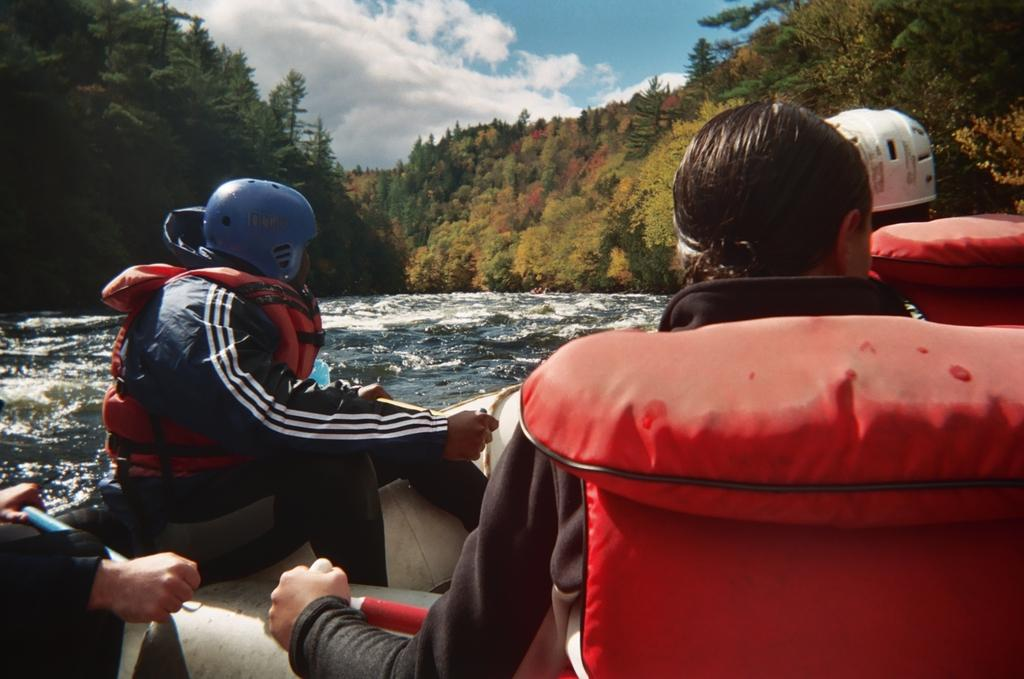What are the people in the image doing? The people in the image are sitting on a boat. What can be seen in the background of the image? The sky with clouds and trees are visible in the background of the image. What is the water visible in the background of the image? The water is visible in the background of the image. What type of impulse can be seen affecting the trees in the image? There is no impulse affecting the trees in the image; they are stationary. How many tomatoes are visible in the image? There are no tomatoes present in the image. 